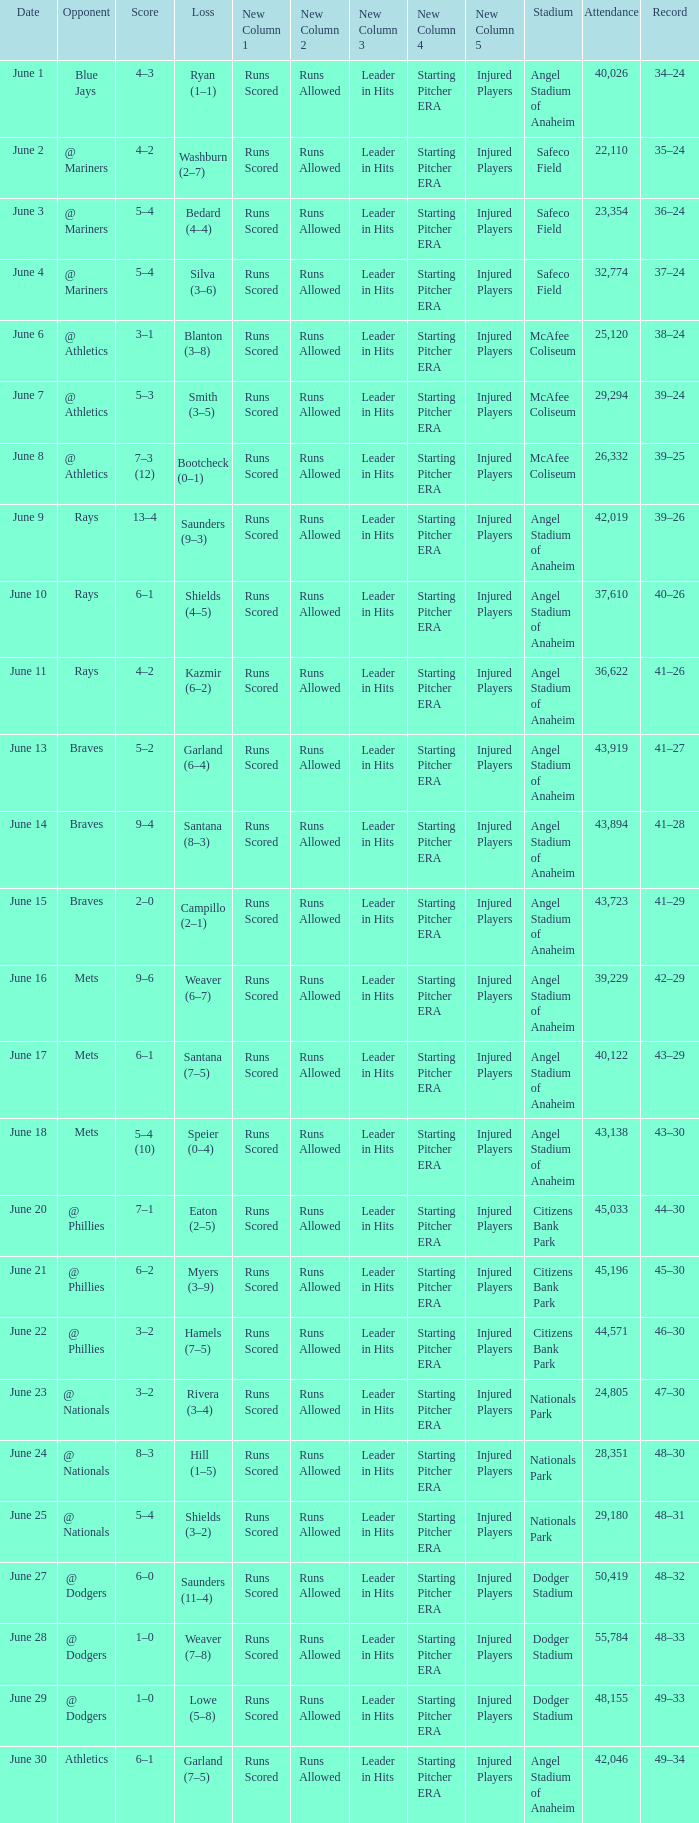Would you mind parsing the complete table? {'header': ['Date', 'Opponent', 'Score', 'Loss', 'New Column 1', 'New Column 2', 'New Column 3', 'New Column 4', 'New Column 5', 'Stadium', 'Attendance', 'Record'], 'rows': [['June 1', 'Blue Jays', '4–3', 'Ryan (1–1)', 'Runs Scored', 'Runs Allowed', 'Leader in Hits', 'Starting Pitcher ERA', 'Injured Players', 'Angel Stadium of Anaheim', '40,026', '34–24'], ['June 2', '@ Mariners', '4–2', 'Washburn (2–7)', 'Runs Scored', 'Runs Allowed', 'Leader in Hits', 'Starting Pitcher ERA', 'Injured Players', 'Safeco Field', '22,110', '35–24'], ['June 3', '@ Mariners', '5–4', 'Bedard (4–4)', 'Runs Scored', 'Runs Allowed', 'Leader in Hits', 'Starting Pitcher ERA', 'Injured Players', 'Safeco Field', '23,354', '36–24'], ['June 4', '@ Mariners', '5–4', 'Silva (3–6)', 'Runs Scored', 'Runs Allowed', 'Leader in Hits', 'Starting Pitcher ERA', 'Injured Players', 'Safeco Field', '32,774', '37–24'], ['June 6', '@ Athletics', '3–1', 'Blanton (3–8)', 'Runs Scored', 'Runs Allowed', 'Leader in Hits', 'Starting Pitcher ERA', 'Injured Players', 'McAfee Coliseum', '25,120', '38–24'], ['June 7', '@ Athletics', '5–3', 'Smith (3–5)', 'Runs Scored', 'Runs Allowed', 'Leader in Hits', 'Starting Pitcher ERA', 'Injured Players', 'McAfee Coliseum', '29,294', '39–24'], ['June 8', '@ Athletics', '7–3 (12)', 'Bootcheck (0–1)', 'Runs Scored', 'Runs Allowed', 'Leader in Hits', 'Starting Pitcher ERA', 'Injured Players', 'McAfee Coliseum', '26,332', '39–25'], ['June 9', 'Rays', '13–4', 'Saunders (9–3)', 'Runs Scored', 'Runs Allowed', 'Leader in Hits', 'Starting Pitcher ERA', 'Injured Players', 'Angel Stadium of Anaheim', '42,019', '39–26'], ['June 10', 'Rays', '6–1', 'Shields (4–5)', 'Runs Scored', 'Runs Allowed', 'Leader in Hits', 'Starting Pitcher ERA', 'Injured Players', 'Angel Stadium of Anaheim', '37,610', '40–26'], ['June 11', 'Rays', '4–2', 'Kazmir (6–2)', 'Runs Scored', 'Runs Allowed', 'Leader in Hits', 'Starting Pitcher ERA', 'Injured Players', 'Angel Stadium of Anaheim', '36,622', '41–26'], ['June 13', 'Braves', '5–2', 'Garland (6–4)', 'Runs Scored', 'Runs Allowed', 'Leader in Hits', 'Starting Pitcher ERA', 'Injured Players', 'Angel Stadium of Anaheim', '43,919', '41–27'], ['June 14', 'Braves', '9–4', 'Santana (8–3)', 'Runs Scored', 'Runs Allowed', 'Leader in Hits', 'Starting Pitcher ERA', 'Injured Players', 'Angel Stadium of Anaheim', '43,894', '41–28'], ['June 15', 'Braves', '2–0', 'Campillo (2–1)', 'Runs Scored', 'Runs Allowed', 'Leader in Hits', 'Starting Pitcher ERA', 'Injured Players', 'Angel Stadium of Anaheim', '43,723', '41–29'], ['June 16', 'Mets', '9–6', 'Weaver (6–7)', 'Runs Scored', 'Runs Allowed', 'Leader in Hits', 'Starting Pitcher ERA', 'Injured Players', 'Angel Stadium of Anaheim', '39,229', '42–29'], ['June 17', 'Mets', '6–1', 'Santana (7–5)', 'Runs Scored', 'Runs Allowed', 'Leader in Hits', 'Starting Pitcher ERA', 'Injured Players', 'Angel Stadium of Anaheim', '40,122', '43–29'], ['June 18', 'Mets', '5–4 (10)', 'Speier (0–4)', 'Runs Scored', 'Runs Allowed', 'Leader in Hits', 'Starting Pitcher ERA', 'Injured Players', 'Angel Stadium of Anaheim', '43,138', '43–30'], ['June 20', '@ Phillies', '7–1', 'Eaton (2–5)', 'Runs Scored', 'Runs Allowed', 'Leader in Hits', 'Starting Pitcher ERA', 'Injured Players', 'Citizens Bank Park', '45,033', '44–30'], ['June 21', '@ Phillies', '6–2', 'Myers (3–9)', 'Runs Scored', 'Runs Allowed', 'Leader in Hits', 'Starting Pitcher ERA', 'Injured Players', 'Citizens Bank Park', '45,196', '45–30'], ['June 22', '@ Phillies', '3–2', 'Hamels (7–5)', 'Runs Scored', 'Runs Allowed', 'Leader in Hits', 'Starting Pitcher ERA', 'Injured Players', 'Citizens Bank Park', '44,571', '46–30'], ['June 23', '@ Nationals', '3–2', 'Rivera (3–4)', 'Runs Scored', 'Runs Allowed', 'Leader in Hits', 'Starting Pitcher ERA', 'Injured Players', 'Nationals Park', '24,805', '47–30'], ['June 24', '@ Nationals', '8–3', 'Hill (1–5)', 'Runs Scored', 'Runs Allowed', 'Leader in Hits', 'Starting Pitcher ERA', 'Injured Players', 'Nationals Park', '28,351', '48–30'], ['June 25', '@ Nationals', '5–4', 'Shields (3–2)', 'Runs Scored', 'Runs Allowed', 'Leader in Hits', 'Starting Pitcher ERA', 'Injured Players', 'Nationals Park', '29,180', '48–31'], ['June 27', '@ Dodgers', '6–0', 'Saunders (11–4)', 'Runs Scored', 'Runs Allowed', 'Leader in Hits', 'Starting Pitcher ERA', 'Injured Players', 'Dodger Stadium', '50,419', '48–32'], ['June 28', '@ Dodgers', '1–0', 'Weaver (7–8)', 'Runs Scored', 'Runs Allowed', 'Leader in Hits', 'Starting Pitcher ERA', 'Injured Players', 'Dodger Stadium', '55,784', '48–33'], ['June 29', '@ Dodgers', '1–0', 'Lowe (5–8)', 'Runs Scored', 'Runs Allowed', 'Leader in Hits', 'Starting Pitcher ERA', 'Injured Players', 'Dodger Stadium', '48,155', '49–33'], ['June 30', 'Athletics', '6–1', 'Garland (7–5)', 'Runs Scored', 'Runs Allowed', 'Leader in Hits', 'Starting Pitcher ERA', 'Injured Players', 'Angel Stadium of Anaheim', '42,046', '49–34']]} What was the score of the game against the Braves with a record of 41–27? 5–2. 